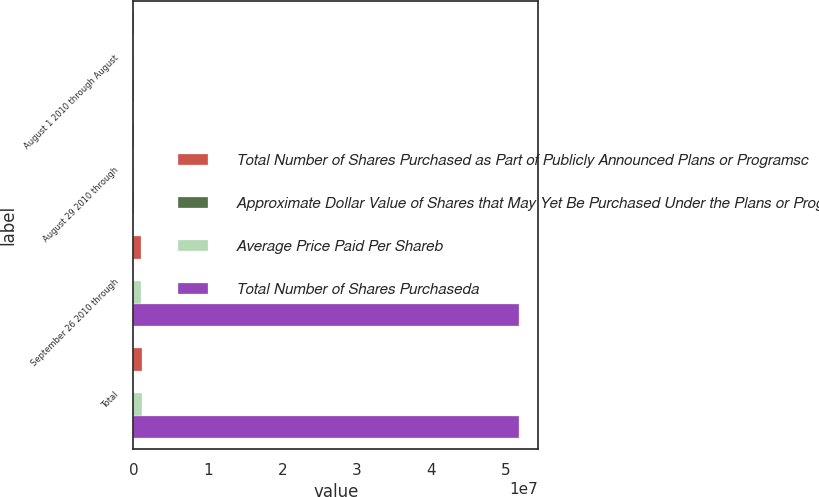Convert chart. <chart><loc_0><loc_0><loc_500><loc_500><stacked_bar_chart><ecel><fcel>August 1 2010 through August<fcel>August 29 2010 through<fcel>September 26 2010 through<fcel>Total<nl><fcel>Total Number of Shares Purchased as Part of Publicly Announced Plans or Programsc<fcel>74879<fcel>50584<fcel>1.01439e+06<fcel>1.13985e+06<nl><fcel>Approximate Dollar Value of Shares that May Yet Be Purchased Under the Plans or Programs<fcel>29.7<fcel>28.88<fcel>31.71<fcel>31.45<nl><fcel>Average Price Paid Per Shareb<fcel>74879<fcel>49565<fcel>1.0138e+06<fcel>1.13824e+06<nl><fcel>Total Number of Shares Purchaseda<fcel>74879<fcel>74879<fcel>5.17671e+07<fcel>5.17671e+07<nl></chart> 